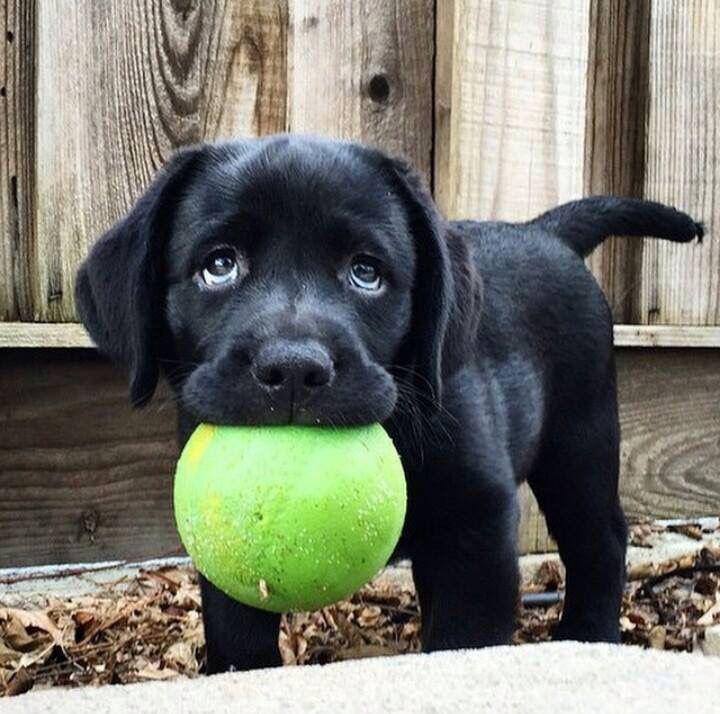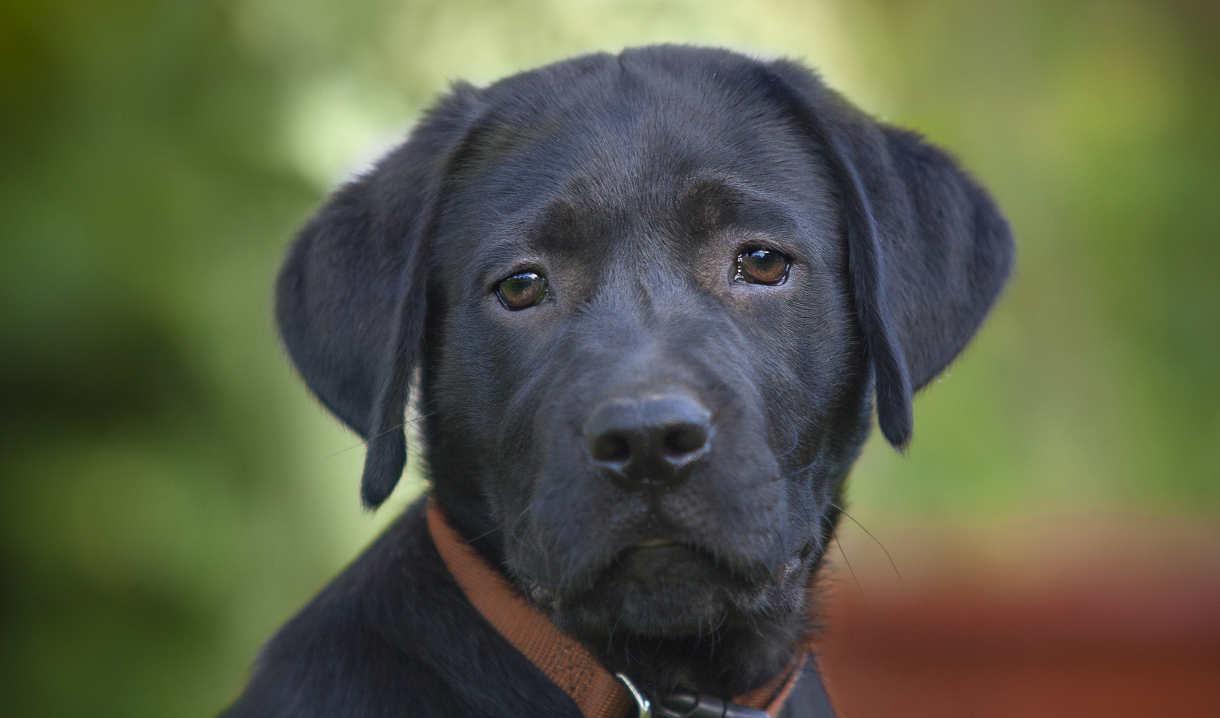The first image is the image on the left, the second image is the image on the right. For the images shown, is this caption "The left image contains no more than one dog." true? Answer yes or no. Yes. The first image is the image on the left, the second image is the image on the right. Given the left and right images, does the statement "Each image contains only one dog, and each dog is a black lab pup." hold true? Answer yes or no. Yes. 